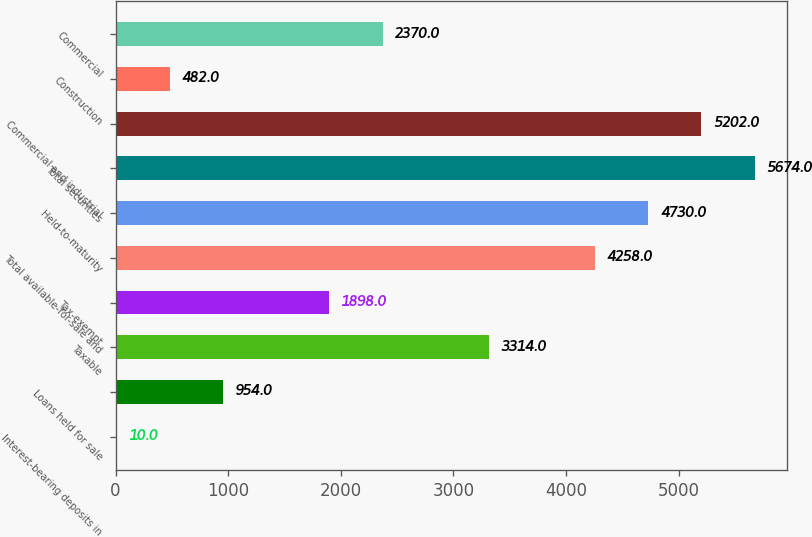Convert chart. <chart><loc_0><loc_0><loc_500><loc_500><bar_chart><fcel>Interest-bearing deposits in<fcel>Loans held for sale<fcel>Taxable<fcel>Tax-exempt<fcel>Total available-for-sale and<fcel>Held-to-maturity<fcel>Total securities<fcel>Commercial and industrial<fcel>Construction<fcel>Commercial<nl><fcel>10<fcel>954<fcel>3314<fcel>1898<fcel>4258<fcel>4730<fcel>5674<fcel>5202<fcel>482<fcel>2370<nl></chart> 